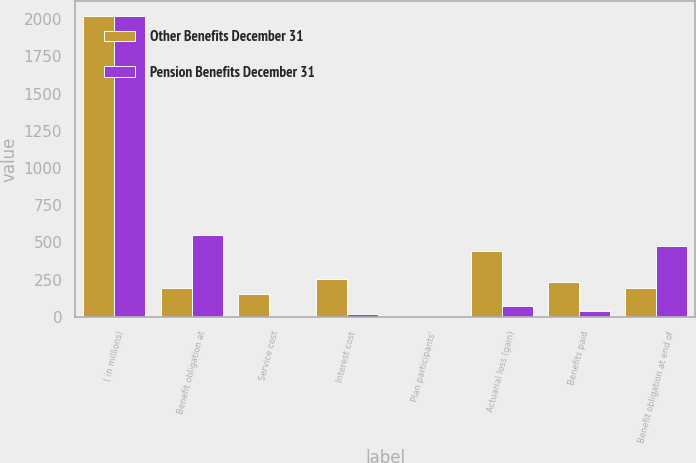<chart> <loc_0><loc_0><loc_500><loc_500><stacked_bar_chart><ecel><fcel>( in millions)<fcel>Benefit obligation at<fcel>Service cost<fcel>Interest cost<fcel>Plan participants'<fcel>Actuarial loss (gain)<fcel>Benefits paid<fcel>Benefit obligation at end of<nl><fcel>Other Benefits December 31<fcel>2018<fcel>196<fcel>157<fcel>254<fcel>6<fcel>441<fcel>235<fcel>196<nl><fcel>Pension Benefits December 31<fcel>2018<fcel>553<fcel>8<fcel>21<fcel>8<fcel>73<fcel>38<fcel>479<nl></chart> 